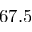Convert formula to latex. <formula><loc_0><loc_0><loc_500><loc_500>6 7 . 5</formula> 